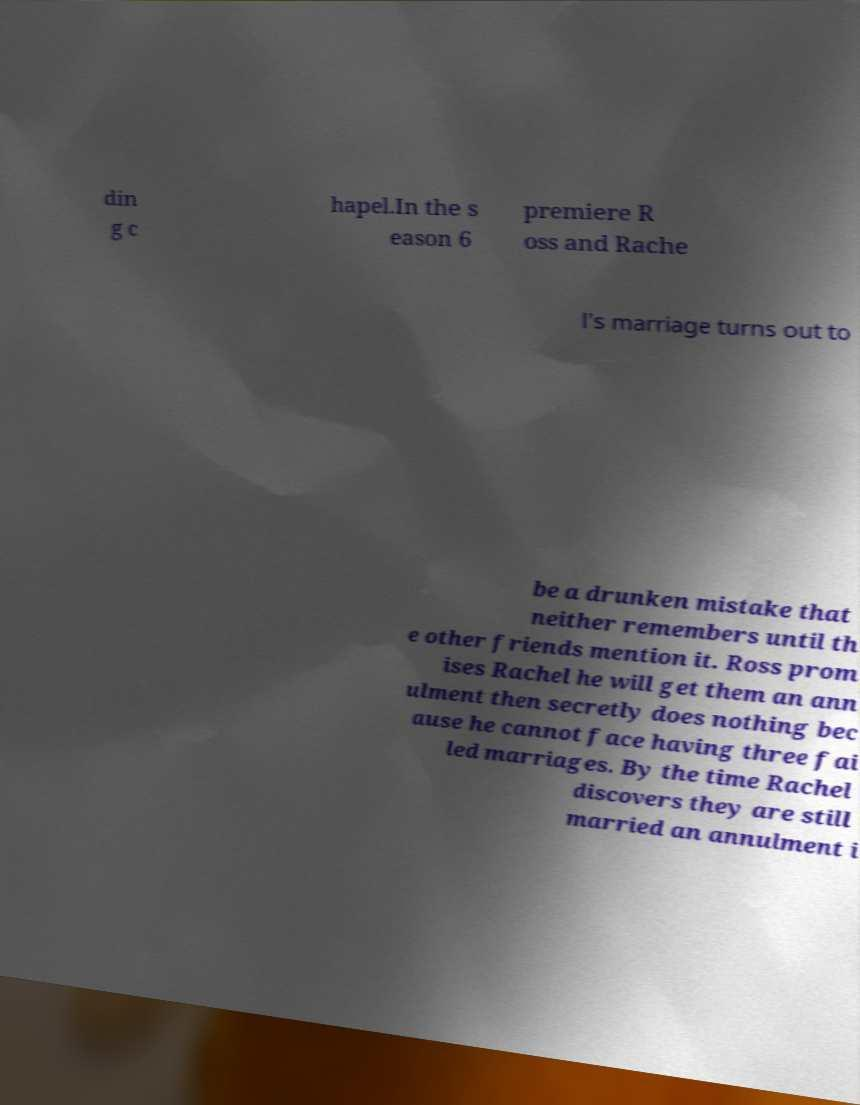Please read and relay the text visible in this image. What does it say? din g c hapel.In the s eason 6 premiere R oss and Rache l's marriage turns out to be a drunken mistake that neither remembers until th e other friends mention it. Ross prom ises Rachel he will get them an ann ulment then secretly does nothing bec ause he cannot face having three fai led marriages. By the time Rachel discovers they are still married an annulment i 